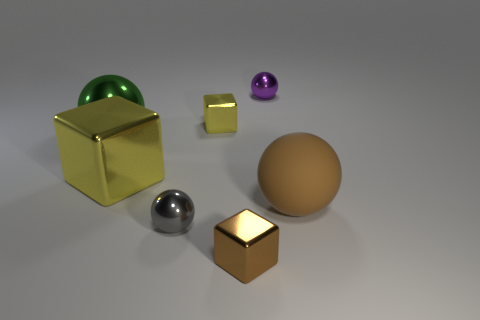Are there any other things that have the same material as the brown ball?
Give a very brief answer. No. There is a green object; does it have the same size as the ball right of the small purple metallic thing?
Your answer should be very brief. Yes. There is a metallic object that is behind the tiny yellow object; what is its color?
Your answer should be very brief. Purple. The small thing that is the same color as the matte ball is what shape?
Your response must be concise. Cube. There is a brown object in front of the brown rubber ball; what shape is it?
Provide a succinct answer. Cube. How many cyan things are big matte balls or small metal cubes?
Make the answer very short. 0. Is the material of the small brown cube the same as the big brown thing?
Offer a very short reply. No. How many tiny shiny things are in front of the purple thing?
Your response must be concise. 3. There is a tiny thing that is behind the green ball and in front of the small purple ball; what material is it?
Your answer should be very brief. Metal. What number of blocks are either rubber things or tiny objects?
Your response must be concise. 2. 